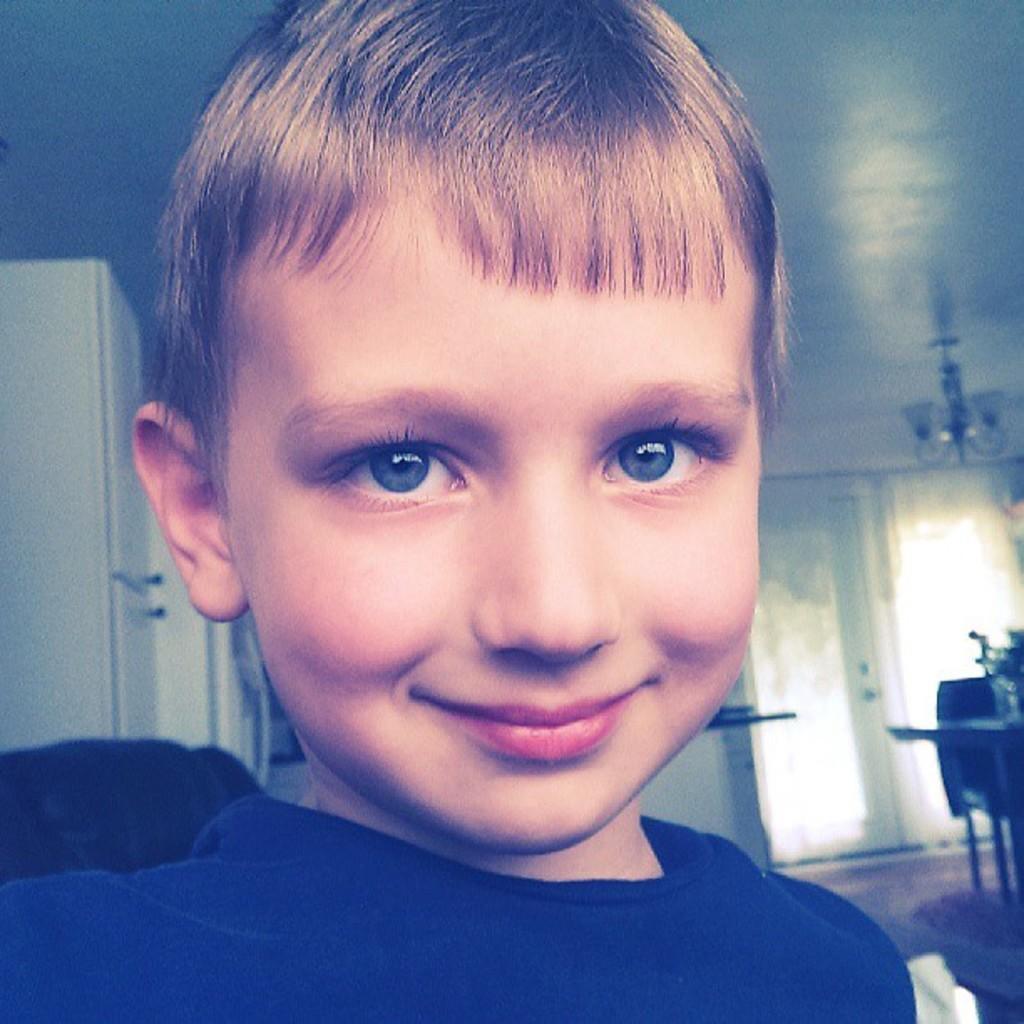In one or two sentences, can you explain what this image depicts? In this image, there is a kid wearing clothes. There is a door on the right side of the image. there is a ceiling in the top right of the image. 